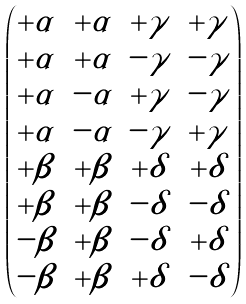Convert formula to latex. <formula><loc_0><loc_0><loc_500><loc_500>\begin{pmatrix} + \alpha & + \alpha & + \gamma & + \gamma \\ + \alpha & + \alpha & - \gamma & - \gamma \\ + \alpha & - \alpha & + \gamma & - \gamma \\ + \alpha & - \alpha & - \gamma & + \gamma \\ + \beta & + \beta & + \delta & + \delta \\ + \beta & + \beta & - \delta & - \delta \\ - \beta & + \beta & - \delta & + \delta \\ - \beta & + \beta & + \delta & - \delta \\ \end{pmatrix}</formula> 